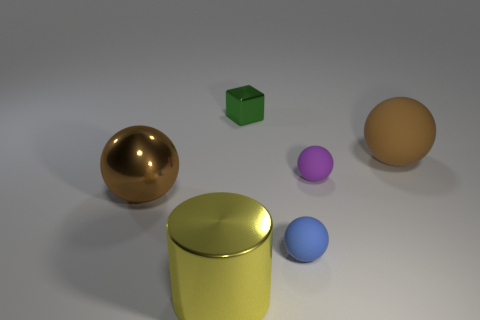What material is the other small thing that is the same shape as the small blue object?
Provide a short and direct response. Rubber. What is the shape of the object that is both left of the small blue object and to the right of the yellow thing?
Ensure brevity in your answer.  Cube. There is a big shiny thing that is in front of the big brown metal sphere; is its color the same as the shiny sphere?
Your answer should be compact. No. Is the shape of the rubber object on the left side of the purple rubber object the same as the large brown object in front of the tiny purple thing?
Offer a terse response. Yes. There is a brown ball left of the big matte sphere; what is its size?
Ensure brevity in your answer.  Large. There is a brown object that is in front of the large brown object to the right of the small metallic thing; what is its size?
Provide a short and direct response. Large. Are there more cyan blocks than big matte spheres?
Keep it short and to the point. No. Are there more purple matte objects that are left of the blue rubber sphere than metal objects on the right side of the yellow cylinder?
Make the answer very short. No. How big is the object that is both behind the purple ball and on the left side of the brown matte ball?
Offer a terse response. Small. How many brown spheres have the same size as the yellow thing?
Give a very brief answer. 2. 